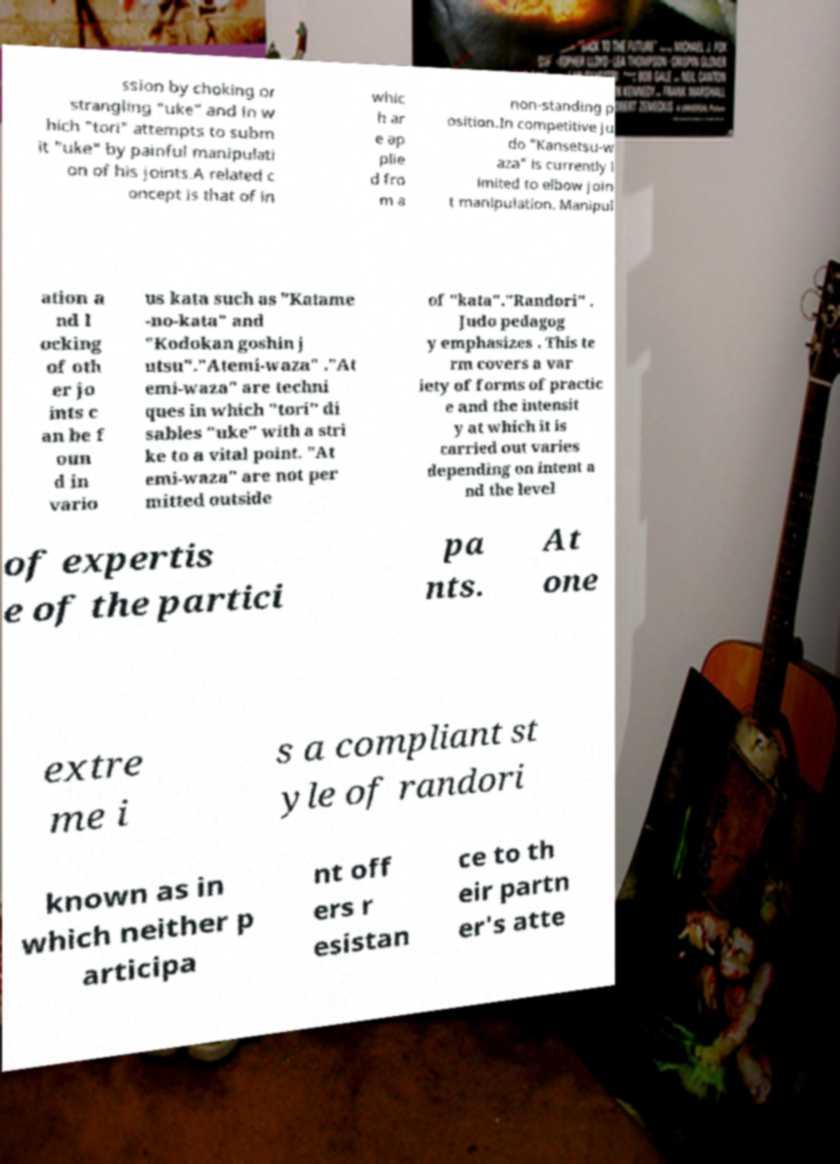Please read and relay the text visible in this image. What does it say? ssion by choking or strangling "uke" and in w hich "tori" attempts to subm it "uke" by painful manipulati on of his joints.A related c oncept is that of in whic h ar e ap plie d fro m a non-standing p osition.In competitive ju do "Kansetsu-w aza" is currently l imited to elbow join t manipulation. Manipul ation a nd l ocking of oth er jo ints c an be f oun d in vario us kata such as "Katame -no-kata" and "Kodokan goshin j utsu"."Atemi-waza" ."At emi-waza" are techni ques in which "tori" di sables "uke" with a stri ke to a vital point. "At emi-waza" are not per mitted outside of "kata"."Randori" . Judo pedagog y emphasizes . This te rm covers a var iety of forms of practic e and the intensit y at which it is carried out varies depending on intent a nd the level of expertis e of the partici pa nts. At one extre me i s a compliant st yle of randori known as in which neither p articipa nt off ers r esistan ce to th eir partn er's atte 